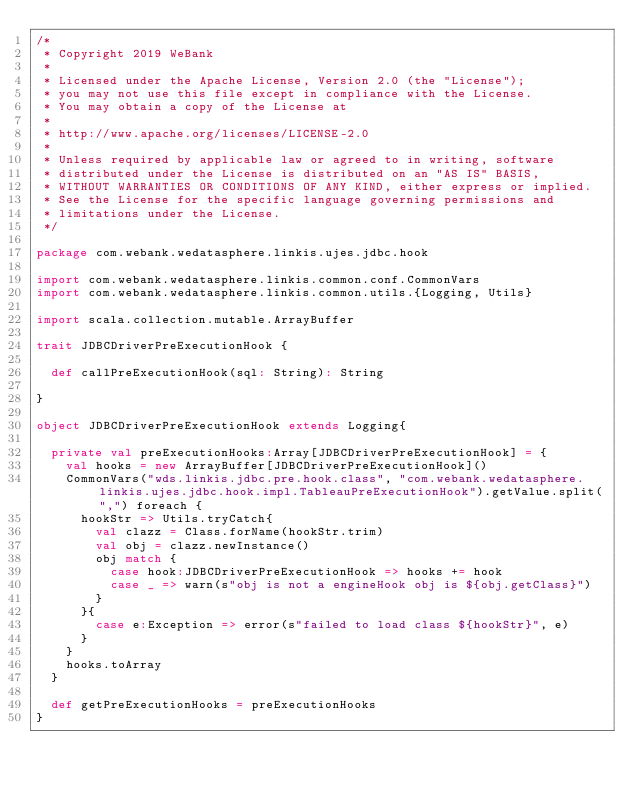<code> <loc_0><loc_0><loc_500><loc_500><_Scala_>/*
 * Copyright 2019 WeBank
 *
 * Licensed under the Apache License, Version 2.0 (the "License");
 * you may not use this file except in compliance with the License.
 * You may obtain a copy of the License at
 *
 * http://www.apache.org/licenses/LICENSE-2.0
 *
 * Unless required by applicable law or agreed to in writing, software
 * distributed under the License is distributed on an "AS IS" BASIS,
 * WITHOUT WARRANTIES OR CONDITIONS OF ANY KIND, either express or implied.
 * See the License for the specific language governing permissions and
 * limitations under the License.
 */

package com.webank.wedatasphere.linkis.ujes.jdbc.hook

import com.webank.wedatasphere.linkis.common.conf.CommonVars
import com.webank.wedatasphere.linkis.common.utils.{Logging, Utils}

import scala.collection.mutable.ArrayBuffer

trait JDBCDriverPreExecutionHook {

  def callPreExecutionHook(sql: String): String

}

object JDBCDriverPreExecutionHook extends Logging{

  private val preExecutionHooks:Array[JDBCDriverPreExecutionHook] = {
    val hooks = new ArrayBuffer[JDBCDriverPreExecutionHook]()
    CommonVars("wds.linkis.jdbc.pre.hook.class", "com.webank.wedatasphere.linkis.ujes.jdbc.hook.impl.TableauPreExecutionHook").getValue.split(",") foreach {
      hookStr => Utils.tryCatch{
        val clazz = Class.forName(hookStr.trim)
        val obj = clazz.newInstance()
        obj match {
          case hook:JDBCDriverPreExecutionHook => hooks += hook
          case _ => warn(s"obj is not a engineHook obj is ${obj.getClass}")
        }
      }{
        case e:Exception => error(s"failed to load class ${hookStr}", e)
      }
    }
    hooks.toArray
  }

  def getPreExecutionHooks = preExecutionHooks
}</code> 